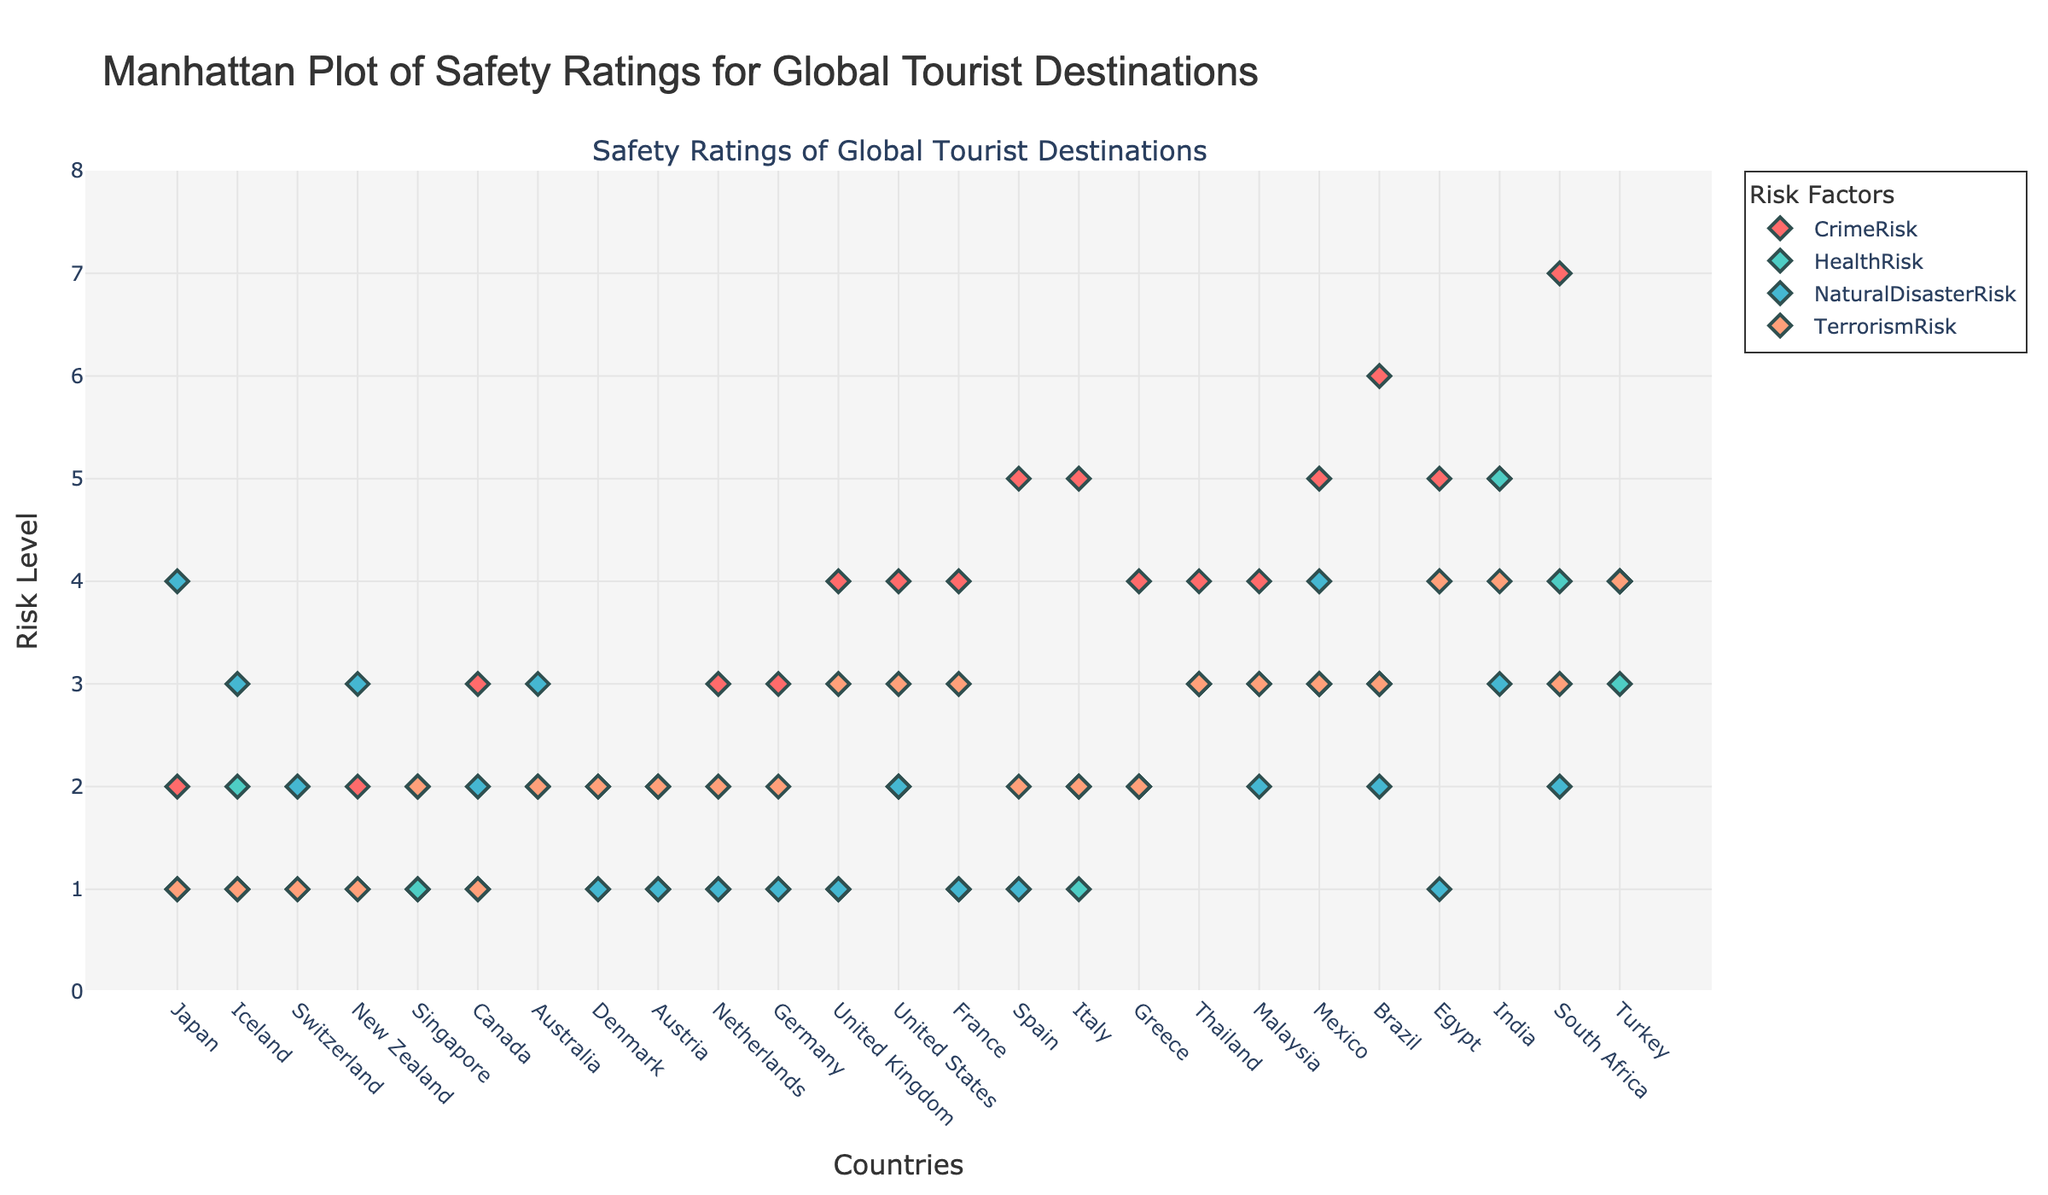What is the overall title of the plot? The overall title of the plot is displayed at the top center of the figure.
Answer: Manhattan Plot of Safety Ratings for Global Tourist Destinations What are the four risk factors represented in this plot? The plot shows four different risk factors as indicated by multiple colored markers. The legend clarifies that these risk factors are Crime Risk, Health Risk, Natural Disaster Risk, and Terrorism Risk.
Answer: Crime Risk, Health Risk, Natural Disaster Risk, Terrorism Risk Which country has the highest Crime Risk according to the plot? To find the country with the highest Crime Risk, look for the highest value of the red diamonds in the Crime Risk series. The highest occurs at the "Johannesburg" data point in the plot.
Answer: South Africa What is the average Health Risk score for the top 5 safest cities? Identify the top 5 safest cities by their Overall Safety Score, then extract their Health Risk scores and calculate the average of these values. The cities are Tokyo (1), Reykjavik (2), Zurich (1), Wellington (1), and Singapore (1), thus the average is (1 + 2 + 1 + 1 + 1) / 5.
Answer: 1.2 Compare the Terrorism Risk between Istanbul and New York City. Which has a higher risk? Locate the data points for Istanbul and New York City in the Terrorism Risk series. Istanbul's marker for Terrorism Risk is at 4, while New York City's is at 3. Hence, Istanbul has a higher Terrorism Risk.
Answer: Istanbul How many cities have a Natural Disaster Risk score of exactly 2? Review the plot for all diamond markers in the Natural Disaster Risk series that are positioned at the value of 2 on the y-axis. The cities are Vancouver, Singapore, Vienna, New York City, Rome, Malaysia, and Brazil. Count these incidences.
Answer: 7 Which city has the lowest Health Risk and is also among the top 5 safest cities? Identify the top 5 safest cities (Tokyo, Reykjavik, Zurich, Wellington, Singapore) and examine the Health Risk for each. The city with the lowest Health Risk among these is Singapore with a Health Risk of 1.
Answer: Zurich and Singapore In terms of Crime Risk, which city is safer: Amsterdam or Paris? Locate the data points for Amsterdam and Paris in the Crime Risk series. Amsterdam has a score of 3 while Paris has a score of 4 in the series. Therefore, Amsterdam is safer in terms of Crime Risk.
Answer: Amsterdam What risk factor appears to influence the lowest overall safety score city the most? Find the lowest overall safety score city, which is Istanbul, and examine the four risk factors for this city. The highest value for Istanbul's risk factors is Terrorism Risk, which is 4.
Answer: Terrorism 